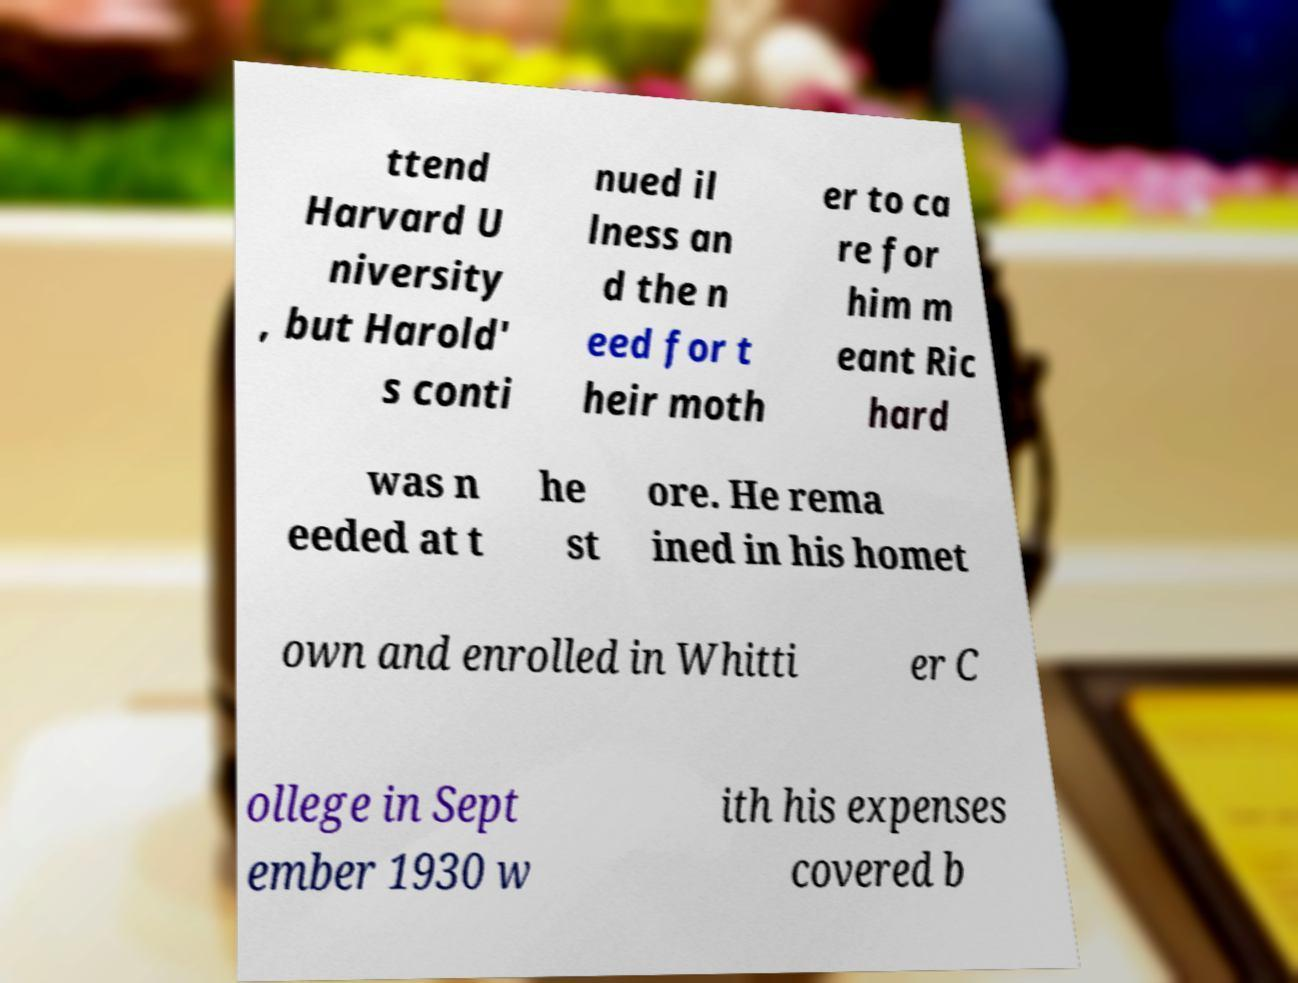Could you assist in decoding the text presented in this image and type it out clearly? ttend Harvard U niversity , but Harold' s conti nued il lness an d the n eed for t heir moth er to ca re for him m eant Ric hard was n eeded at t he st ore. He rema ined in his homet own and enrolled in Whitti er C ollege in Sept ember 1930 w ith his expenses covered b 